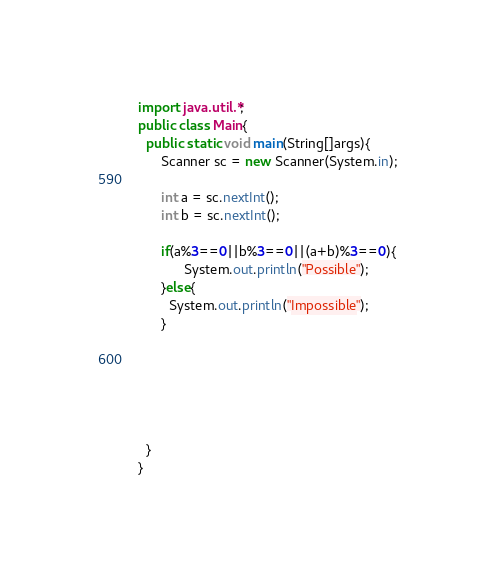<code> <loc_0><loc_0><loc_500><loc_500><_Java_>import java.util.*;
public class Main{
  public static void main(String[]args){
      Scanner sc = new Scanner(System.in);

      int a = sc.nextInt();
      int b = sc.nextInt();

      if(a%3==0||b%3==0||(a+b)%3==0){
            System.out.println("Possible");
      }else{
        System.out.println("Impossible");
      }






  }
}
</code> 